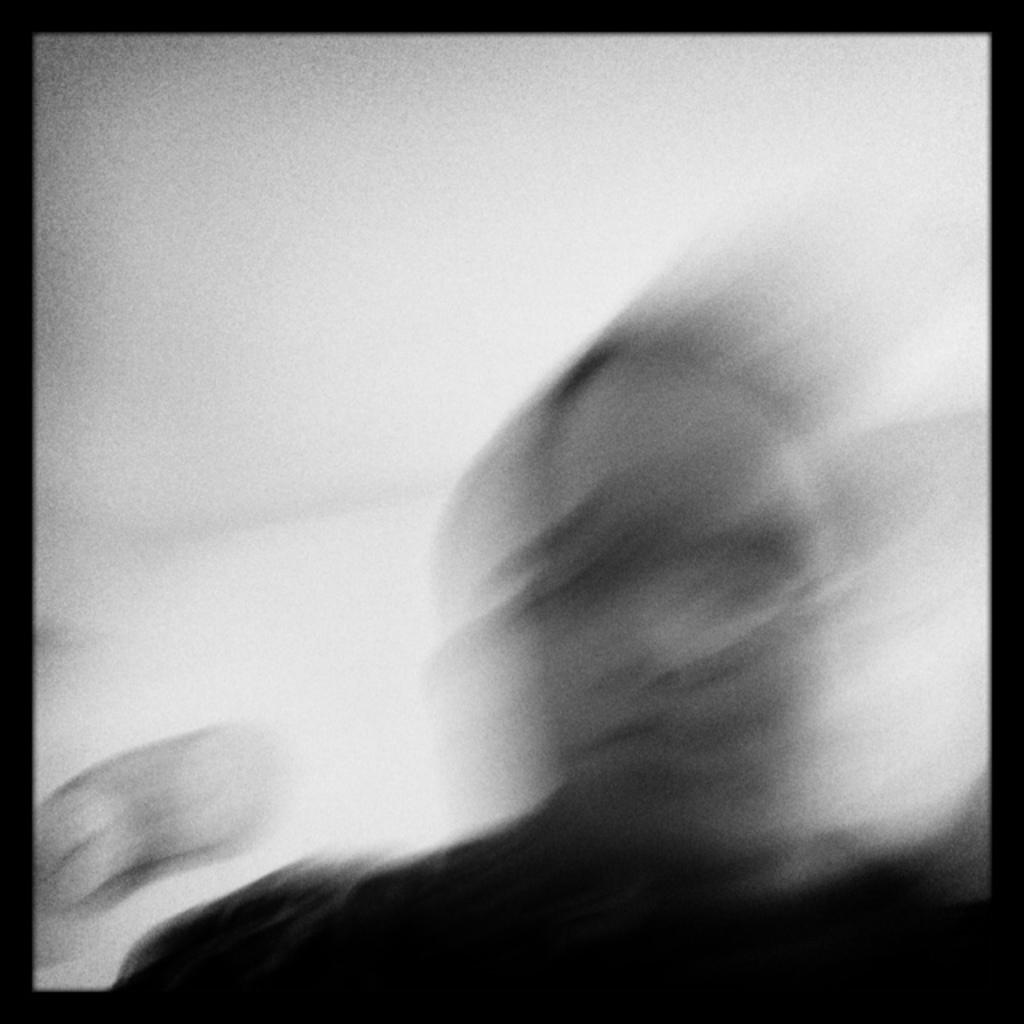What is the main subject of the image? There is a person in the image. What color scheme is used in the image? The image is in black and white. Can you tell me how many eyes the person has in the image? The image is in black and white, so it is not possible to determine the number of eyes the person has based on the image alone. 